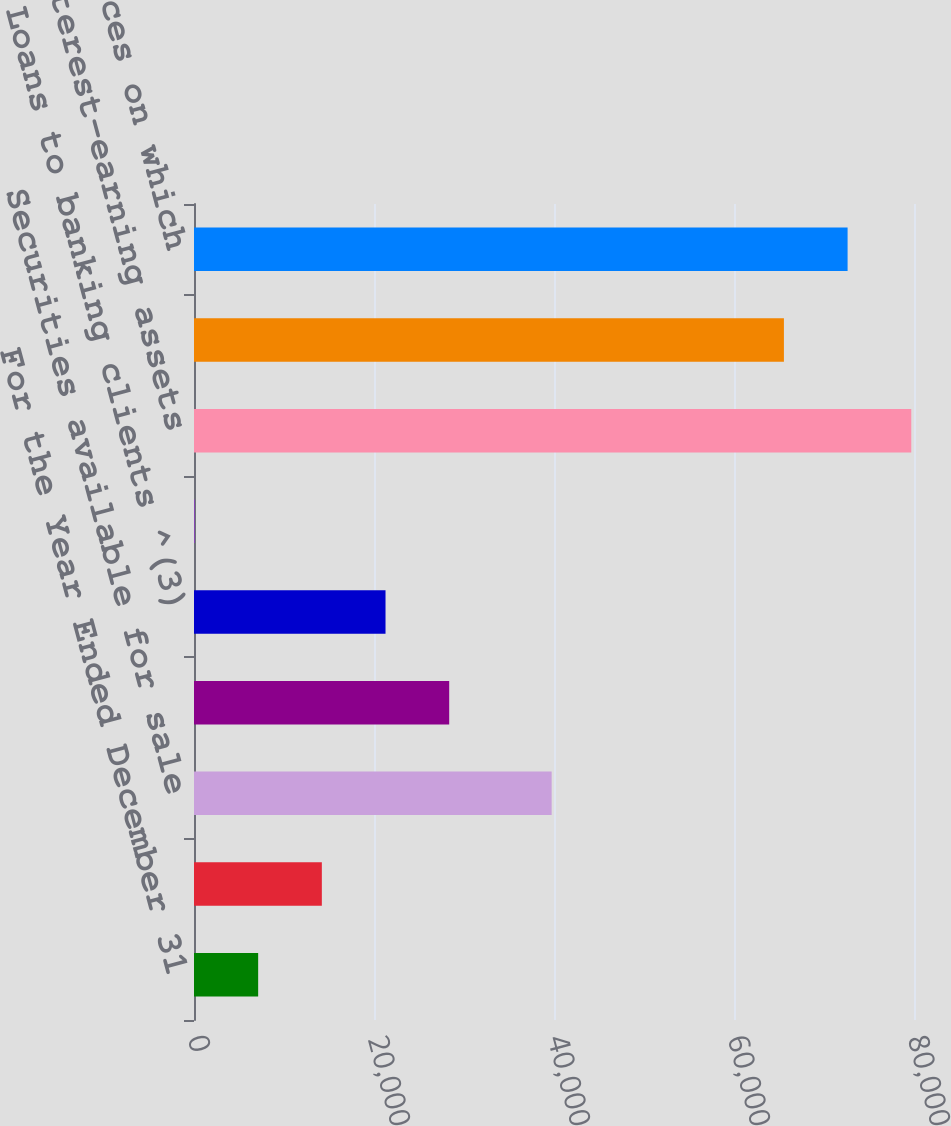Convert chart. <chart><loc_0><loc_0><loc_500><loc_500><bar_chart><fcel>For the Year Ended December 31<fcel>Cash and cash equivalents^ (1)<fcel>Securities available for sale<fcel>Securities held to maturity<fcel>Loans to banking clients ^(3)<fcel>Other interest-earning assets<fcel>Total interest-earning assets<fcel>Interest-bearing banking<fcel>Total sources on which<nl><fcel>7129.3<fcel>14204.6<fcel>39739<fcel>28355.2<fcel>21279.9<fcel>54<fcel>79696.6<fcel>65546<fcel>72621.3<nl></chart> 